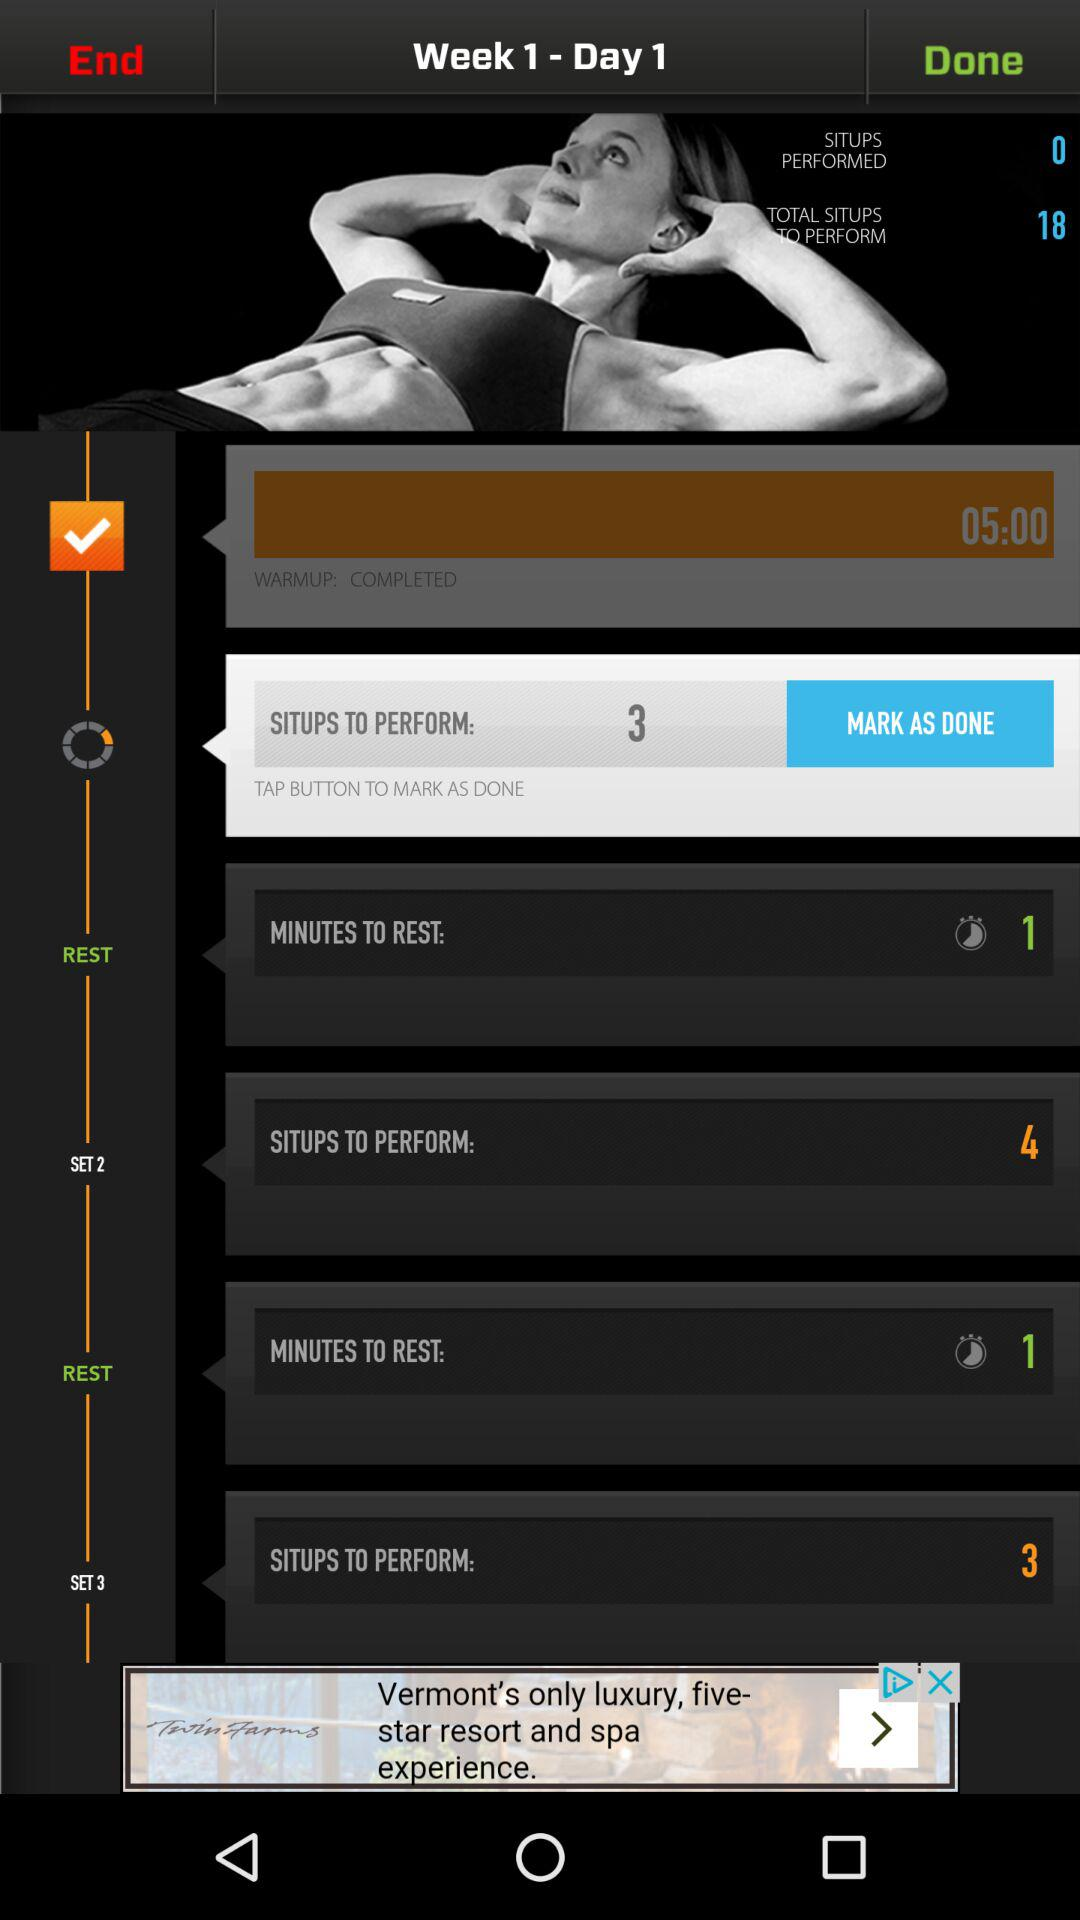How many weeks in total are there?
When the provided information is insufficient, respond with <no answer>. <no answer> 